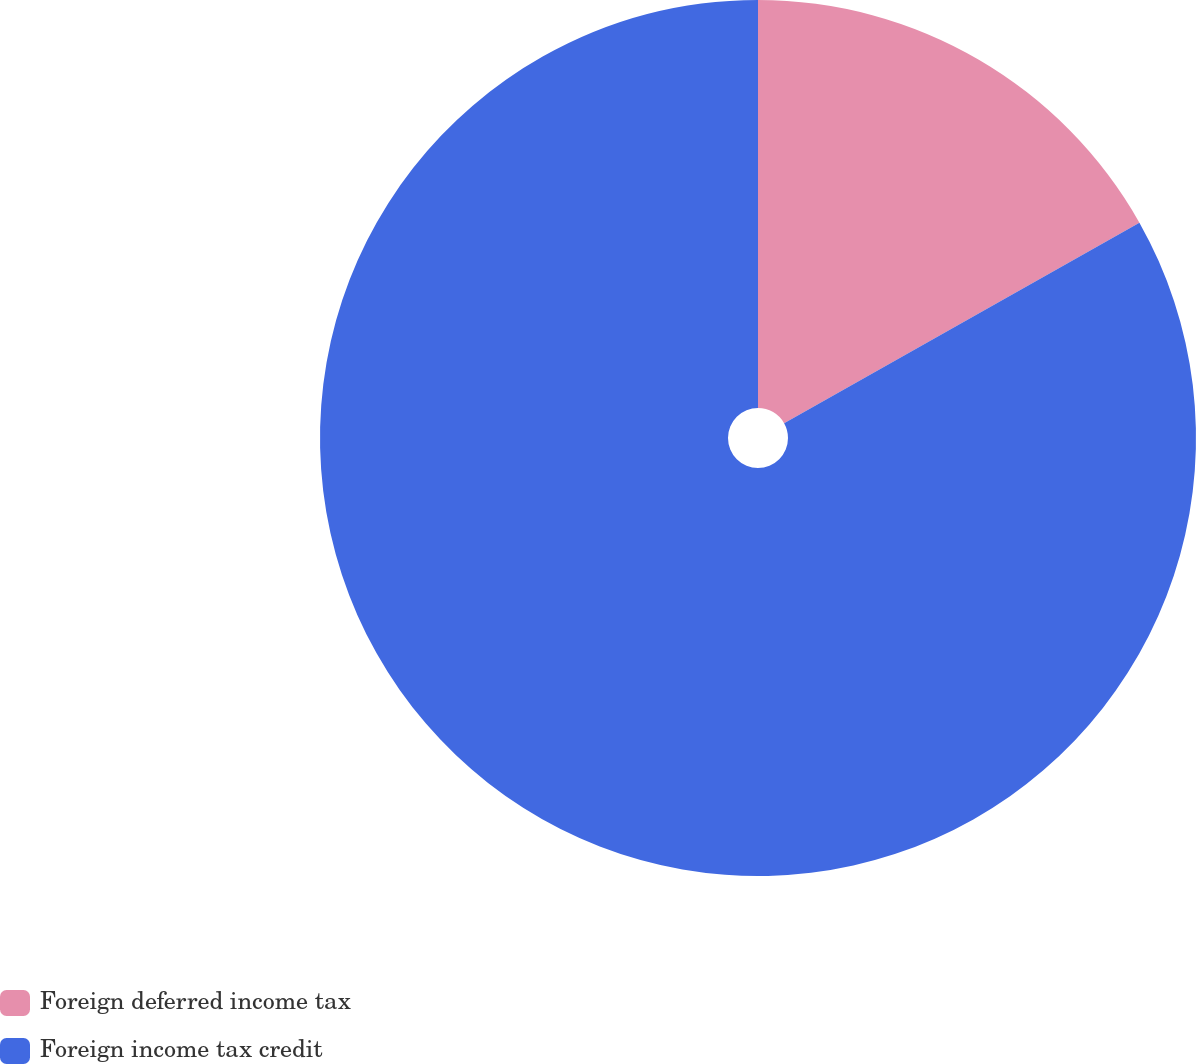Convert chart to OTSL. <chart><loc_0><loc_0><loc_500><loc_500><pie_chart><fcel>Foreign deferred income tax<fcel>Foreign income tax credit<nl><fcel>16.82%<fcel>83.18%<nl></chart> 